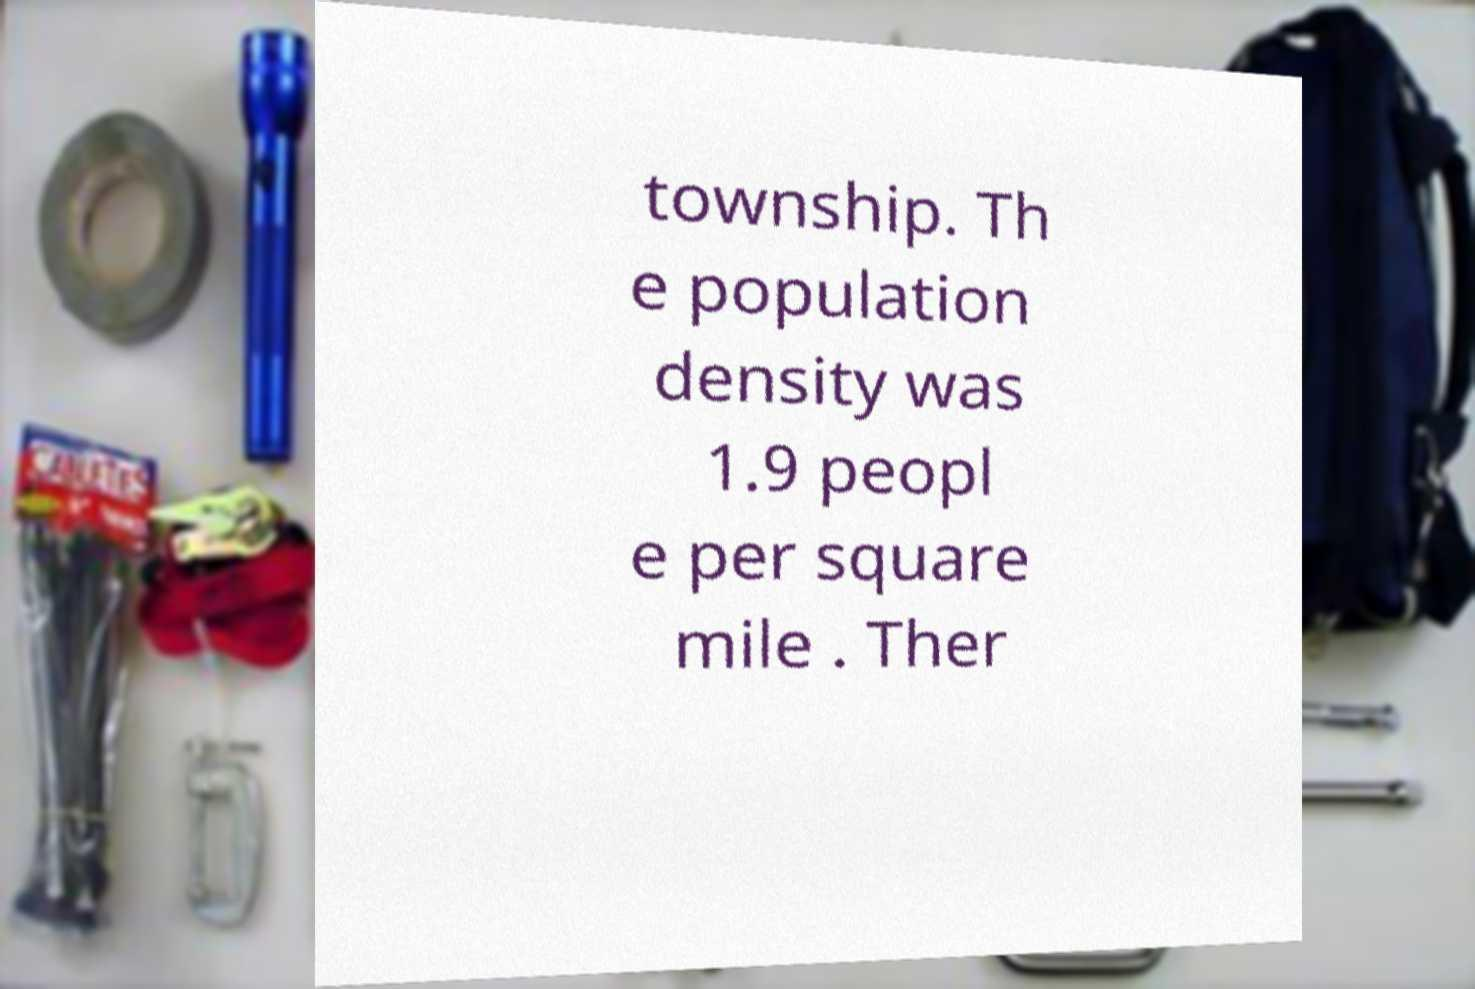I need the written content from this picture converted into text. Can you do that? township. Th e population density was 1.9 peopl e per square mile . Ther 